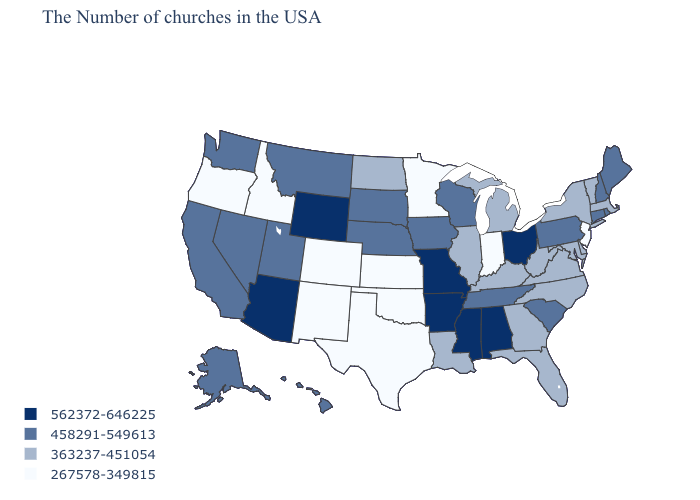What is the value of Virginia?
Be succinct. 363237-451054. Which states have the lowest value in the Northeast?
Answer briefly. New Jersey. Does South Dakota have the highest value in the MidWest?
Give a very brief answer. No. What is the value of Alabama?
Be succinct. 562372-646225. What is the value of Montana?
Short answer required. 458291-549613. Name the states that have a value in the range 267578-349815?
Write a very short answer. New Jersey, Indiana, Minnesota, Kansas, Oklahoma, Texas, Colorado, New Mexico, Idaho, Oregon. Does Indiana have the lowest value in the MidWest?
Concise answer only. Yes. What is the lowest value in the USA?
Be succinct. 267578-349815. Among the states that border Washington , which have the lowest value?
Write a very short answer. Idaho, Oregon. What is the value of Kentucky?
Be succinct. 363237-451054. Name the states that have a value in the range 267578-349815?
Short answer required. New Jersey, Indiana, Minnesota, Kansas, Oklahoma, Texas, Colorado, New Mexico, Idaho, Oregon. Name the states that have a value in the range 458291-549613?
Short answer required. Maine, Rhode Island, New Hampshire, Connecticut, Pennsylvania, South Carolina, Tennessee, Wisconsin, Iowa, Nebraska, South Dakota, Utah, Montana, Nevada, California, Washington, Alaska, Hawaii. Name the states that have a value in the range 458291-549613?
Concise answer only. Maine, Rhode Island, New Hampshire, Connecticut, Pennsylvania, South Carolina, Tennessee, Wisconsin, Iowa, Nebraska, South Dakota, Utah, Montana, Nevada, California, Washington, Alaska, Hawaii. Name the states that have a value in the range 562372-646225?
Short answer required. Ohio, Alabama, Mississippi, Missouri, Arkansas, Wyoming, Arizona. Name the states that have a value in the range 458291-549613?
Concise answer only. Maine, Rhode Island, New Hampshire, Connecticut, Pennsylvania, South Carolina, Tennessee, Wisconsin, Iowa, Nebraska, South Dakota, Utah, Montana, Nevada, California, Washington, Alaska, Hawaii. 